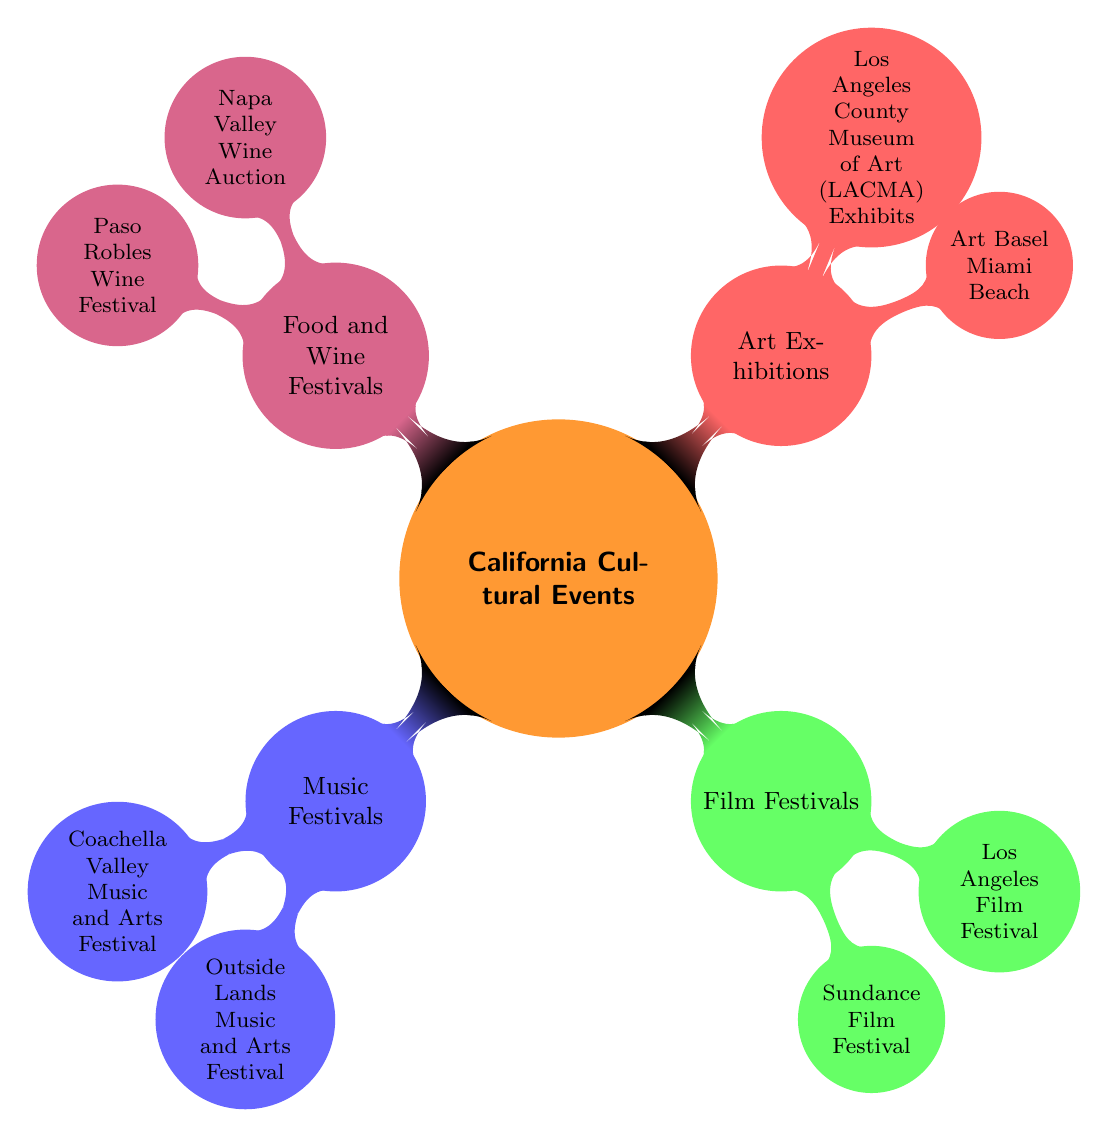What are the two main categories of cultural events represented in the diagram? The diagram shows four main categories of cultural events: Music Festivals, Film Festivals, Art Exhibitions, and Food and Wine Festivals. The two main categories among them can be Music Festivals and Film Festivals.
Answer: Music Festivals, Film Festivals How many music festivals are listed in the diagram? In the diagram under the Music Festivals category, there are two listed: Coachella Valley Music and Arts Festival and Outside Lands Music and Arts Festival.
Answer: 2 What is the specific event associated with the Food and Wine Festivals category? The Food and Wine Festivals category lists two specific events: Napa Valley Wine Auction and Paso Robles Wine Festival. Since the question asks for a specific event, either can be considered, but Napa Valley Wine Auction can be highlighted.
Answer: Napa Valley Wine Auction Which type of cultural events has the most entries in this diagram? Examining each category, Music Festivals and Food and Wine Festivals have two entries each, while Film Festivals and Art Exhibitions have two entries each as well. Therefore, all categories have an equal number of entries. However, since they all have the same number, we can say they tie for the most.
Answer: All categories tie Is the Los Angeles Film Festival categorized under Film Festivals or Art Exhibitions? The Los Angeles Film Festival is specifically grouped under the Film Festivals category in the diagram. There are no overlapping categories in this structure, as each event is distinctly categorized.
Answer: Film Festivals Which cultural event is listed last in the diagram? To determine the last event in the diagram, we follow the branches to the end. The last node in the Food and Wine Festivals category is the Paso Robles Wine Festival, as it is positioned last in that hierarchy.
Answer: Paso Robles Wine Festival 